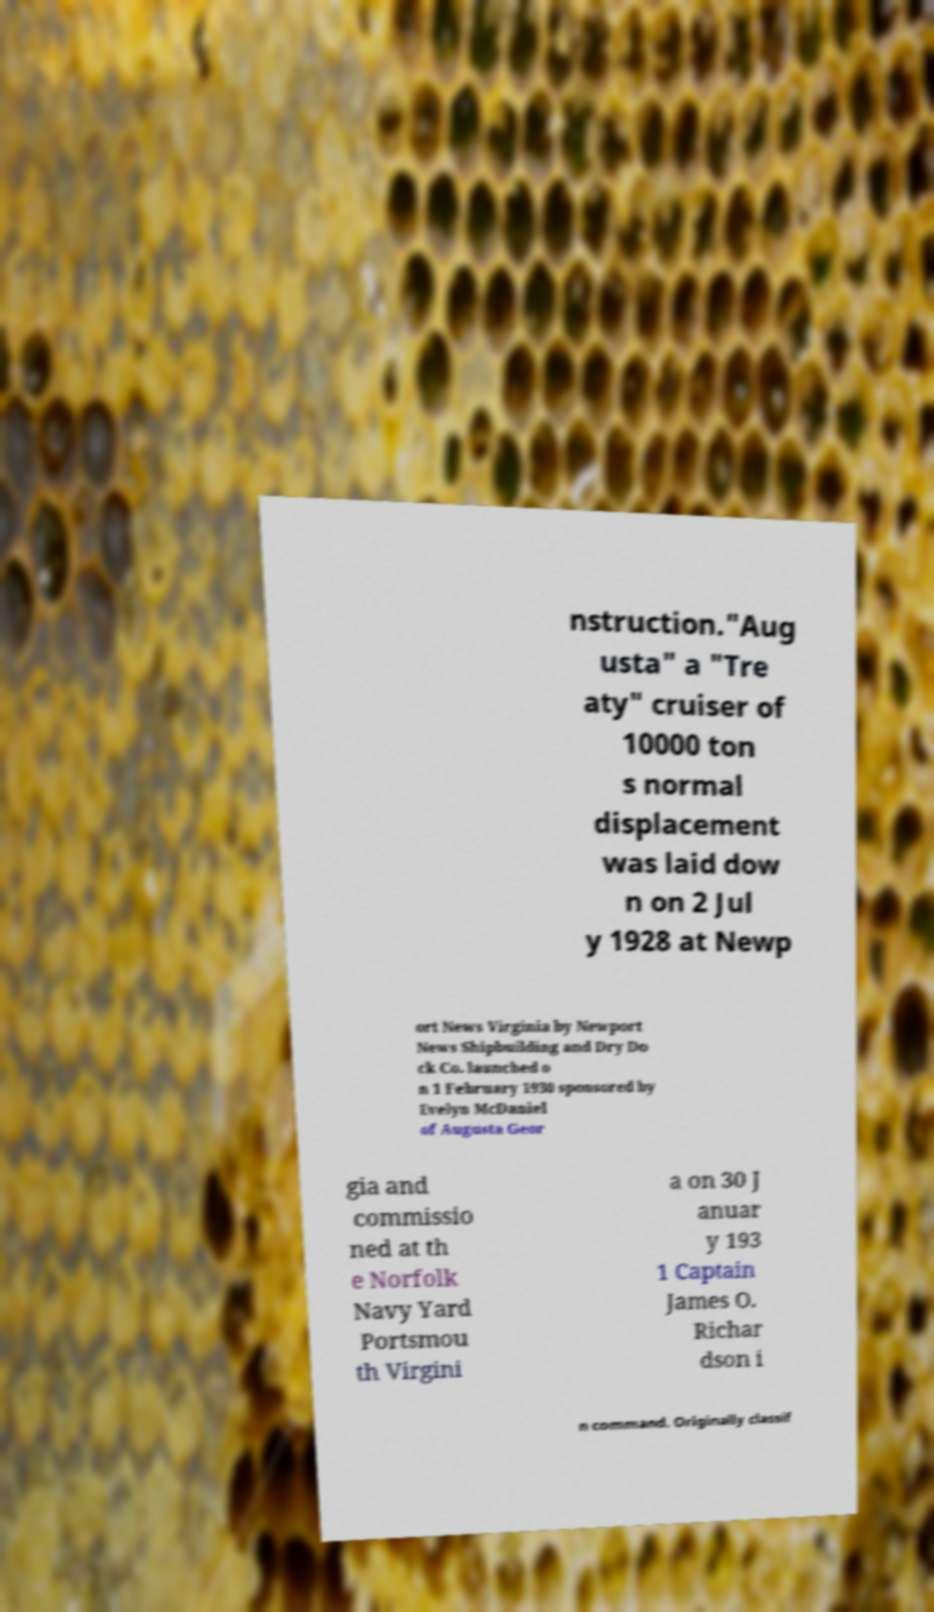I need the written content from this picture converted into text. Can you do that? nstruction."Aug usta" a "Tre aty" cruiser of 10000 ton s normal displacement was laid dow n on 2 Jul y 1928 at Newp ort News Virginia by Newport News Shipbuilding and Dry Do ck Co. launched o n 1 February 1930 sponsored by Evelyn McDaniel of Augusta Geor gia and commissio ned at th e Norfolk Navy Yard Portsmou th Virgini a on 30 J anuar y 193 1 Captain James O. Richar dson i n command. Originally classif 